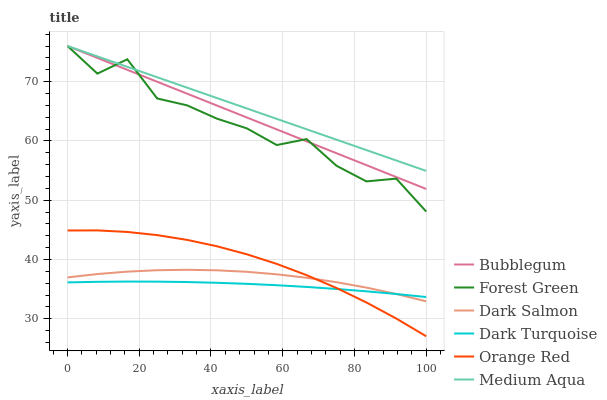Does Dark Salmon have the minimum area under the curve?
Answer yes or no. No. Does Dark Salmon have the maximum area under the curve?
Answer yes or no. No. Is Dark Salmon the smoothest?
Answer yes or no. No. Is Dark Salmon the roughest?
Answer yes or no. No. Does Dark Salmon have the lowest value?
Answer yes or no. No. Does Dark Salmon have the highest value?
Answer yes or no. No. Is Dark Salmon less than Forest Green?
Answer yes or no. Yes. Is Bubblegum greater than Orange Red?
Answer yes or no. Yes. Does Dark Salmon intersect Forest Green?
Answer yes or no. No. 